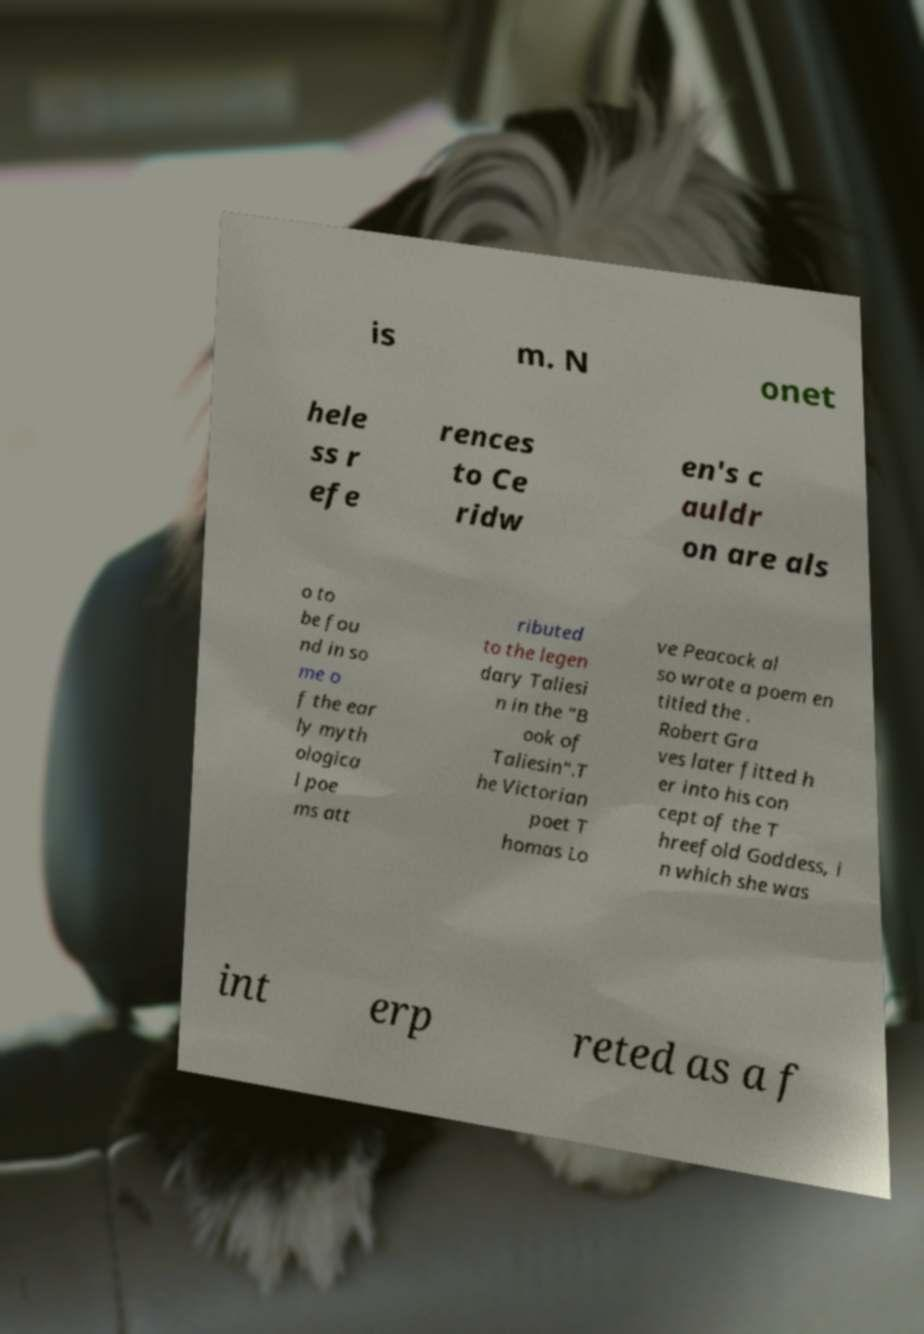Please read and relay the text visible in this image. What does it say? is m. N onet hele ss r efe rences to Ce ridw en's c auldr on are als o to be fou nd in so me o f the ear ly myth ologica l poe ms att ributed to the legen dary Taliesi n in the "B ook of Taliesin".T he Victorian poet T homas Lo ve Peacock al so wrote a poem en titled the . Robert Gra ves later fitted h er into his con cept of the T hreefold Goddess, i n which she was int erp reted as a f 